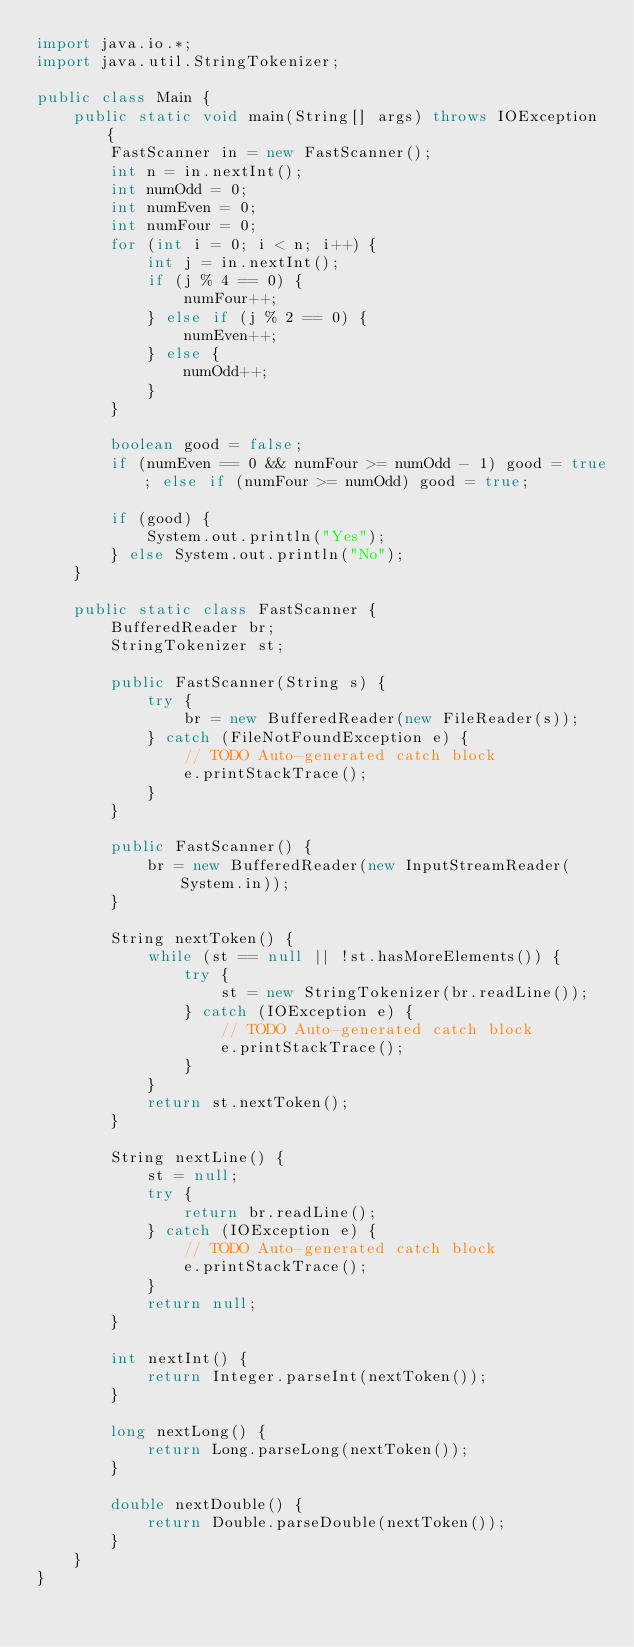<code> <loc_0><loc_0><loc_500><loc_500><_Java_>import java.io.*;
import java.util.StringTokenizer;

public class Main {
    public static void main(String[] args) throws IOException {
        FastScanner in = new FastScanner();
        int n = in.nextInt();
        int numOdd = 0;
        int numEven = 0;
        int numFour = 0;
        for (int i = 0; i < n; i++) {
            int j = in.nextInt();
            if (j % 4 == 0) {
                numFour++;
            } else if (j % 2 == 0) {
                numEven++;
            } else {
                numOdd++;
            }
        }
        
        boolean good = false;
        if (numEven == 0 && numFour >= numOdd - 1) good = true; else if (numFour >= numOdd) good = true;
        
        if (good) {
            System.out.println("Yes");
        } else System.out.println("No");
    }

    public static class FastScanner {
        BufferedReader br;
        StringTokenizer st;

        public FastScanner(String s) {
            try {
                br = new BufferedReader(new FileReader(s));
            } catch (FileNotFoundException e) {
                // TODO Auto-generated catch block
                e.printStackTrace();
            }
        }

        public FastScanner() {
            br = new BufferedReader(new InputStreamReader(System.in));
        }

        String nextToken() {
            while (st == null || !st.hasMoreElements()) {
                try {
                    st = new StringTokenizer(br.readLine());
                } catch (IOException e) {
                    // TODO Auto-generated catch block
                    e.printStackTrace();
                }
            }
            return st.nextToken();
        }

        String nextLine() {
            st = null;
            try {
                return br.readLine();
            } catch (IOException e) {
                // TODO Auto-generated catch block
                e.printStackTrace();
            }
            return null;
        }

        int nextInt() {
            return Integer.parseInt(nextToken());
        }

        long nextLong() {
            return Long.parseLong(nextToken());
        }

        double nextDouble() {
            return Double.parseDouble(nextToken());
        }
    }
}
</code> 